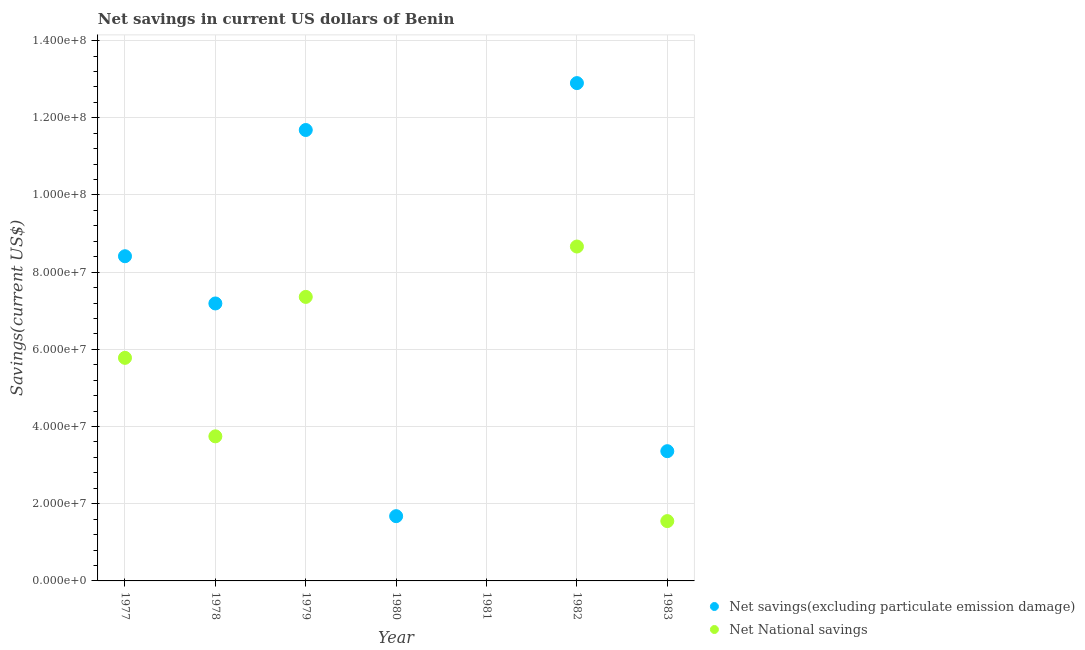How many different coloured dotlines are there?
Provide a succinct answer. 2. Is the number of dotlines equal to the number of legend labels?
Keep it short and to the point. No. What is the net national savings in 1982?
Provide a short and direct response. 8.66e+07. Across all years, what is the maximum net savings(excluding particulate emission damage)?
Make the answer very short. 1.29e+08. Across all years, what is the minimum net national savings?
Your answer should be very brief. 0. In which year was the net national savings maximum?
Keep it short and to the point. 1982. What is the total net savings(excluding particulate emission damage) in the graph?
Your answer should be very brief. 4.52e+08. What is the difference between the net savings(excluding particulate emission damage) in 1979 and that in 1980?
Offer a very short reply. 1.00e+08. What is the difference between the net national savings in 1979 and the net savings(excluding particulate emission damage) in 1977?
Offer a very short reply. -1.05e+07. What is the average net national savings per year?
Provide a short and direct response. 3.87e+07. In the year 1978, what is the difference between the net national savings and net savings(excluding particulate emission damage)?
Your response must be concise. -3.44e+07. In how many years, is the net savings(excluding particulate emission damage) greater than 12000000 US$?
Your response must be concise. 6. What is the ratio of the net savings(excluding particulate emission damage) in 1977 to that in 1979?
Provide a short and direct response. 0.72. Is the difference between the net savings(excluding particulate emission damage) in 1979 and 1982 greater than the difference between the net national savings in 1979 and 1982?
Provide a short and direct response. Yes. What is the difference between the highest and the second highest net national savings?
Offer a very short reply. 1.31e+07. What is the difference between the highest and the lowest net national savings?
Your answer should be very brief. 8.66e+07. In how many years, is the net national savings greater than the average net national savings taken over all years?
Make the answer very short. 3. Is the sum of the net national savings in 1977 and 1982 greater than the maximum net savings(excluding particulate emission damage) across all years?
Your answer should be compact. Yes. Is the net national savings strictly greater than the net savings(excluding particulate emission damage) over the years?
Your answer should be compact. No. How many dotlines are there?
Your answer should be compact. 2. How many years are there in the graph?
Ensure brevity in your answer.  7. Does the graph contain grids?
Offer a terse response. Yes. Where does the legend appear in the graph?
Keep it short and to the point. Bottom right. How many legend labels are there?
Keep it short and to the point. 2. What is the title of the graph?
Offer a very short reply. Net savings in current US dollars of Benin. Does "Investment" appear as one of the legend labels in the graph?
Make the answer very short. No. What is the label or title of the X-axis?
Provide a short and direct response. Year. What is the label or title of the Y-axis?
Ensure brevity in your answer.  Savings(current US$). What is the Savings(current US$) in Net savings(excluding particulate emission damage) in 1977?
Keep it short and to the point. 8.41e+07. What is the Savings(current US$) of Net National savings in 1977?
Offer a very short reply. 5.78e+07. What is the Savings(current US$) of Net savings(excluding particulate emission damage) in 1978?
Make the answer very short. 7.19e+07. What is the Savings(current US$) of Net National savings in 1978?
Your answer should be very brief. 3.75e+07. What is the Savings(current US$) of Net savings(excluding particulate emission damage) in 1979?
Make the answer very short. 1.17e+08. What is the Savings(current US$) of Net National savings in 1979?
Give a very brief answer. 7.36e+07. What is the Savings(current US$) of Net savings(excluding particulate emission damage) in 1980?
Your answer should be very brief. 1.68e+07. What is the Savings(current US$) in Net savings(excluding particulate emission damage) in 1981?
Your answer should be very brief. 0. What is the Savings(current US$) of Net National savings in 1981?
Ensure brevity in your answer.  0. What is the Savings(current US$) in Net savings(excluding particulate emission damage) in 1982?
Provide a short and direct response. 1.29e+08. What is the Savings(current US$) in Net National savings in 1982?
Your answer should be very brief. 8.66e+07. What is the Savings(current US$) in Net savings(excluding particulate emission damage) in 1983?
Your answer should be compact. 3.36e+07. What is the Savings(current US$) of Net National savings in 1983?
Keep it short and to the point. 1.55e+07. Across all years, what is the maximum Savings(current US$) of Net savings(excluding particulate emission damage)?
Make the answer very short. 1.29e+08. Across all years, what is the maximum Savings(current US$) of Net National savings?
Give a very brief answer. 8.66e+07. Across all years, what is the minimum Savings(current US$) in Net savings(excluding particulate emission damage)?
Offer a terse response. 0. Across all years, what is the minimum Savings(current US$) of Net National savings?
Provide a short and direct response. 0. What is the total Savings(current US$) in Net savings(excluding particulate emission damage) in the graph?
Give a very brief answer. 4.52e+08. What is the total Savings(current US$) in Net National savings in the graph?
Ensure brevity in your answer.  2.71e+08. What is the difference between the Savings(current US$) of Net savings(excluding particulate emission damage) in 1977 and that in 1978?
Make the answer very short. 1.22e+07. What is the difference between the Savings(current US$) of Net National savings in 1977 and that in 1978?
Your answer should be very brief. 2.03e+07. What is the difference between the Savings(current US$) in Net savings(excluding particulate emission damage) in 1977 and that in 1979?
Offer a terse response. -3.27e+07. What is the difference between the Savings(current US$) in Net National savings in 1977 and that in 1979?
Provide a succinct answer. -1.58e+07. What is the difference between the Savings(current US$) of Net savings(excluding particulate emission damage) in 1977 and that in 1980?
Offer a terse response. 6.73e+07. What is the difference between the Savings(current US$) in Net savings(excluding particulate emission damage) in 1977 and that in 1982?
Your answer should be compact. -4.49e+07. What is the difference between the Savings(current US$) in Net National savings in 1977 and that in 1982?
Your response must be concise. -2.88e+07. What is the difference between the Savings(current US$) in Net savings(excluding particulate emission damage) in 1977 and that in 1983?
Provide a short and direct response. 5.05e+07. What is the difference between the Savings(current US$) in Net National savings in 1977 and that in 1983?
Make the answer very short. 4.23e+07. What is the difference between the Savings(current US$) of Net savings(excluding particulate emission damage) in 1978 and that in 1979?
Your answer should be very brief. -4.49e+07. What is the difference between the Savings(current US$) of Net National savings in 1978 and that in 1979?
Give a very brief answer. -3.61e+07. What is the difference between the Savings(current US$) of Net savings(excluding particulate emission damage) in 1978 and that in 1980?
Your answer should be compact. 5.51e+07. What is the difference between the Savings(current US$) in Net savings(excluding particulate emission damage) in 1978 and that in 1982?
Give a very brief answer. -5.71e+07. What is the difference between the Savings(current US$) in Net National savings in 1978 and that in 1982?
Ensure brevity in your answer.  -4.92e+07. What is the difference between the Savings(current US$) of Net savings(excluding particulate emission damage) in 1978 and that in 1983?
Your response must be concise. 3.83e+07. What is the difference between the Savings(current US$) of Net National savings in 1978 and that in 1983?
Keep it short and to the point. 2.20e+07. What is the difference between the Savings(current US$) in Net savings(excluding particulate emission damage) in 1979 and that in 1980?
Your answer should be compact. 1.00e+08. What is the difference between the Savings(current US$) of Net savings(excluding particulate emission damage) in 1979 and that in 1982?
Offer a terse response. -1.22e+07. What is the difference between the Savings(current US$) in Net National savings in 1979 and that in 1982?
Keep it short and to the point. -1.31e+07. What is the difference between the Savings(current US$) of Net savings(excluding particulate emission damage) in 1979 and that in 1983?
Provide a succinct answer. 8.32e+07. What is the difference between the Savings(current US$) in Net National savings in 1979 and that in 1983?
Ensure brevity in your answer.  5.81e+07. What is the difference between the Savings(current US$) in Net savings(excluding particulate emission damage) in 1980 and that in 1982?
Provide a succinct answer. -1.12e+08. What is the difference between the Savings(current US$) in Net savings(excluding particulate emission damage) in 1980 and that in 1983?
Give a very brief answer. -1.68e+07. What is the difference between the Savings(current US$) of Net savings(excluding particulate emission damage) in 1982 and that in 1983?
Keep it short and to the point. 9.54e+07. What is the difference between the Savings(current US$) of Net National savings in 1982 and that in 1983?
Offer a very short reply. 7.11e+07. What is the difference between the Savings(current US$) in Net savings(excluding particulate emission damage) in 1977 and the Savings(current US$) in Net National savings in 1978?
Provide a succinct answer. 4.67e+07. What is the difference between the Savings(current US$) of Net savings(excluding particulate emission damage) in 1977 and the Savings(current US$) of Net National savings in 1979?
Provide a short and direct response. 1.05e+07. What is the difference between the Savings(current US$) of Net savings(excluding particulate emission damage) in 1977 and the Savings(current US$) of Net National savings in 1982?
Your response must be concise. -2.51e+06. What is the difference between the Savings(current US$) in Net savings(excluding particulate emission damage) in 1977 and the Savings(current US$) in Net National savings in 1983?
Ensure brevity in your answer.  6.86e+07. What is the difference between the Savings(current US$) of Net savings(excluding particulate emission damage) in 1978 and the Savings(current US$) of Net National savings in 1979?
Make the answer very short. -1.70e+06. What is the difference between the Savings(current US$) of Net savings(excluding particulate emission damage) in 1978 and the Savings(current US$) of Net National savings in 1982?
Give a very brief answer. -1.48e+07. What is the difference between the Savings(current US$) of Net savings(excluding particulate emission damage) in 1978 and the Savings(current US$) of Net National savings in 1983?
Offer a terse response. 5.64e+07. What is the difference between the Savings(current US$) of Net savings(excluding particulate emission damage) in 1979 and the Savings(current US$) of Net National savings in 1982?
Ensure brevity in your answer.  3.02e+07. What is the difference between the Savings(current US$) of Net savings(excluding particulate emission damage) in 1979 and the Savings(current US$) of Net National savings in 1983?
Ensure brevity in your answer.  1.01e+08. What is the difference between the Savings(current US$) of Net savings(excluding particulate emission damage) in 1980 and the Savings(current US$) of Net National savings in 1982?
Offer a terse response. -6.99e+07. What is the difference between the Savings(current US$) in Net savings(excluding particulate emission damage) in 1980 and the Savings(current US$) in Net National savings in 1983?
Keep it short and to the point. 1.28e+06. What is the difference between the Savings(current US$) in Net savings(excluding particulate emission damage) in 1982 and the Savings(current US$) in Net National savings in 1983?
Offer a terse response. 1.13e+08. What is the average Savings(current US$) of Net savings(excluding particulate emission damage) per year?
Give a very brief answer. 6.46e+07. What is the average Savings(current US$) in Net National savings per year?
Offer a terse response. 3.87e+07. In the year 1977, what is the difference between the Savings(current US$) of Net savings(excluding particulate emission damage) and Savings(current US$) of Net National savings?
Offer a terse response. 2.63e+07. In the year 1978, what is the difference between the Savings(current US$) in Net savings(excluding particulate emission damage) and Savings(current US$) in Net National savings?
Offer a very short reply. 3.44e+07. In the year 1979, what is the difference between the Savings(current US$) in Net savings(excluding particulate emission damage) and Savings(current US$) in Net National savings?
Offer a very short reply. 4.32e+07. In the year 1982, what is the difference between the Savings(current US$) of Net savings(excluding particulate emission damage) and Savings(current US$) of Net National savings?
Ensure brevity in your answer.  4.23e+07. In the year 1983, what is the difference between the Savings(current US$) of Net savings(excluding particulate emission damage) and Savings(current US$) of Net National savings?
Offer a very short reply. 1.81e+07. What is the ratio of the Savings(current US$) in Net savings(excluding particulate emission damage) in 1977 to that in 1978?
Provide a short and direct response. 1.17. What is the ratio of the Savings(current US$) of Net National savings in 1977 to that in 1978?
Your response must be concise. 1.54. What is the ratio of the Savings(current US$) of Net savings(excluding particulate emission damage) in 1977 to that in 1979?
Make the answer very short. 0.72. What is the ratio of the Savings(current US$) in Net National savings in 1977 to that in 1979?
Ensure brevity in your answer.  0.79. What is the ratio of the Savings(current US$) of Net savings(excluding particulate emission damage) in 1977 to that in 1980?
Your response must be concise. 5.01. What is the ratio of the Savings(current US$) of Net savings(excluding particulate emission damage) in 1977 to that in 1982?
Give a very brief answer. 0.65. What is the ratio of the Savings(current US$) in Net National savings in 1977 to that in 1982?
Keep it short and to the point. 0.67. What is the ratio of the Savings(current US$) in Net savings(excluding particulate emission damage) in 1977 to that in 1983?
Your answer should be very brief. 2.5. What is the ratio of the Savings(current US$) of Net National savings in 1977 to that in 1983?
Give a very brief answer. 3.73. What is the ratio of the Savings(current US$) of Net savings(excluding particulate emission damage) in 1978 to that in 1979?
Your answer should be compact. 0.62. What is the ratio of the Savings(current US$) of Net National savings in 1978 to that in 1979?
Offer a terse response. 0.51. What is the ratio of the Savings(current US$) in Net savings(excluding particulate emission damage) in 1978 to that in 1980?
Your answer should be very brief. 4.28. What is the ratio of the Savings(current US$) of Net savings(excluding particulate emission damage) in 1978 to that in 1982?
Your response must be concise. 0.56. What is the ratio of the Savings(current US$) in Net National savings in 1978 to that in 1982?
Make the answer very short. 0.43. What is the ratio of the Savings(current US$) of Net savings(excluding particulate emission damage) in 1978 to that in 1983?
Keep it short and to the point. 2.14. What is the ratio of the Savings(current US$) in Net National savings in 1978 to that in 1983?
Offer a terse response. 2.42. What is the ratio of the Savings(current US$) of Net savings(excluding particulate emission damage) in 1979 to that in 1980?
Your answer should be compact. 6.96. What is the ratio of the Savings(current US$) in Net savings(excluding particulate emission damage) in 1979 to that in 1982?
Your response must be concise. 0.91. What is the ratio of the Savings(current US$) in Net National savings in 1979 to that in 1982?
Give a very brief answer. 0.85. What is the ratio of the Savings(current US$) of Net savings(excluding particulate emission damage) in 1979 to that in 1983?
Provide a short and direct response. 3.48. What is the ratio of the Savings(current US$) in Net National savings in 1979 to that in 1983?
Offer a very short reply. 4.75. What is the ratio of the Savings(current US$) in Net savings(excluding particulate emission damage) in 1980 to that in 1982?
Provide a succinct answer. 0.13. What is the ratio of the Savings(current US$) of Net savings(excluding particulate emission damage) in 1980 to that in 1983?
Your answer should be very brief. 0.5. What is the ratio of the Savings(current US$) of Net savings(excluding particulate emission damage) in 1982 to that in 1983?
Provide a succinct answer. 3.84. What is the ratio of the Savings(current US$) in Net National savings in 1982 to that in 1983?
Make the answer very short. 5.59. What is the difference between the highest and the second highest Savings(current US$) of Net savings(excluding particulate emission damage)?
Offer a very short reply. 1.22e+07. What is the difference between the highest and the second highest Savings(current US$) of Net National savings?
Offer a very short reply. 1.31e+07. What is the difference between the highest and the lowest Savings(current US$) of Net savings(excluding particulate emission damage)?
Offer a terse response. 1.29e+08. What is the difference between the highest and the lowest Savings(current US$) in Net National savings?
Your response must be concise. 8.66e+07. 